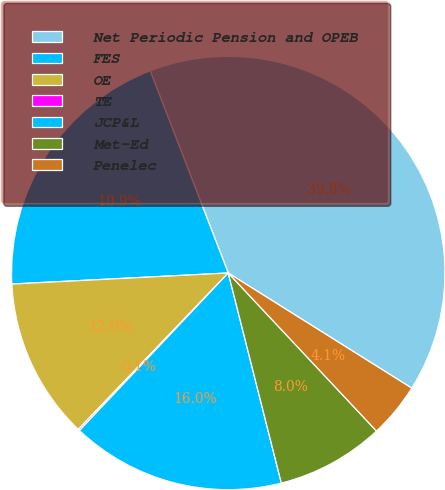Convert chart. <chart><loc_0><loc_0><loc_500><loc_500><pie_chart><fcel>Net Periodic Pension and OPEB<fcel>FES<fcel>OE<fcel>TE<fcel>JCP&L<fcel>Met-Ed<fcel>Penelec<nl><fcel>39.79%<fcel>19.95%<fcel>12.02%<fcel>0.12%<fcel>15.99%<fcel>8.05%<fcel>4.09%<nl></chart> 